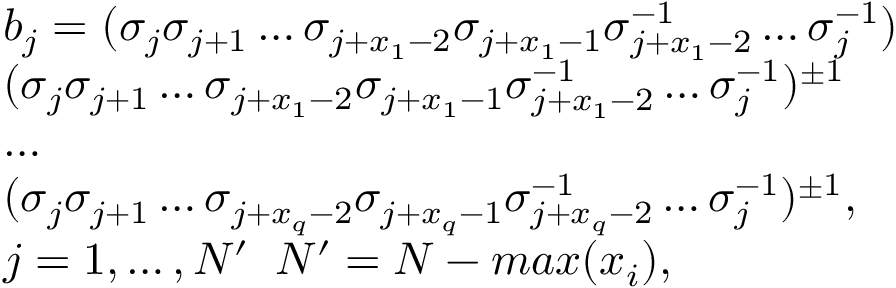Convert formula to latex. <formula><loc_0><loc_0><loc_500><loc_500>\begin{array} { l } { b _ { j } = ( \sigma _ { j } \sigma _ { j + 1 } \dots \sigma _ { j + x _ { 1 } - 2 } \sigma _ { j + x _ { 1 } - 1 } \sigma _ { j + x _ { 1 } - 2 } ^ { - 1 } \dots \sigma _ { j } ^ { - 1 } ) } \\ { ( \sigma _ { j } \sigma _ { j + 1 } \dots \sigma _ { j + x _ { 1 } - 2 } \sigma _ { j + x _ { 1 } - 1 } \sigma _ { j + x _ { 1 } - 2 } ^ { - 1 } \dots \sigma _ { j } ^ { - 1 } ) ^ { \pm 1 } } \\ { \dots } \\ { ( \sigma _ { j } \sigma _ { j + 1 } \dots \sigma _ { j + x _ { q } - 2 } \sigma _ { j + x _ { q } - 1 } \sigma _ { j + x _ { q } - 2 } ^ { - 1 } \dots \sigma _ { j } ^ { - 1 } ) ^ { \pm 1 } , } \\ { j = 1 , \dots , N ^ { \prime } \, N ^ { \prime } = N - \max ( x _ { i } ) , } \end{array}</formula> 